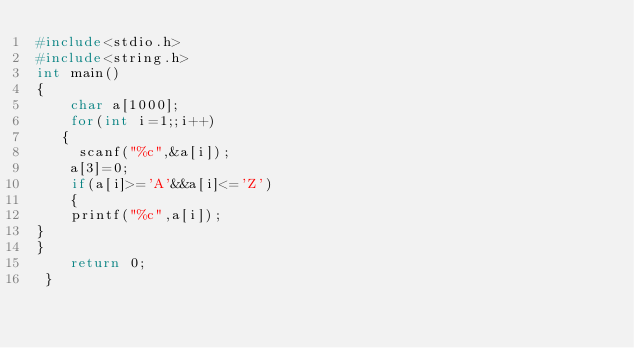Convert code to text. <code><loc_0><loc_0><loc_500><loc_500><_C_>#include<stdio.h>
#include<string.h>
int main()
{
    char a[1000];
    for(int i=1;;i++)
   {
	 scanf("%c",&a[i]);
    a[3]=0;
	if(a[i]>='A'&&a[i]<='Z')
	{
	printf("%c",a[i]);
}
}
	return 0;
 } </code> 